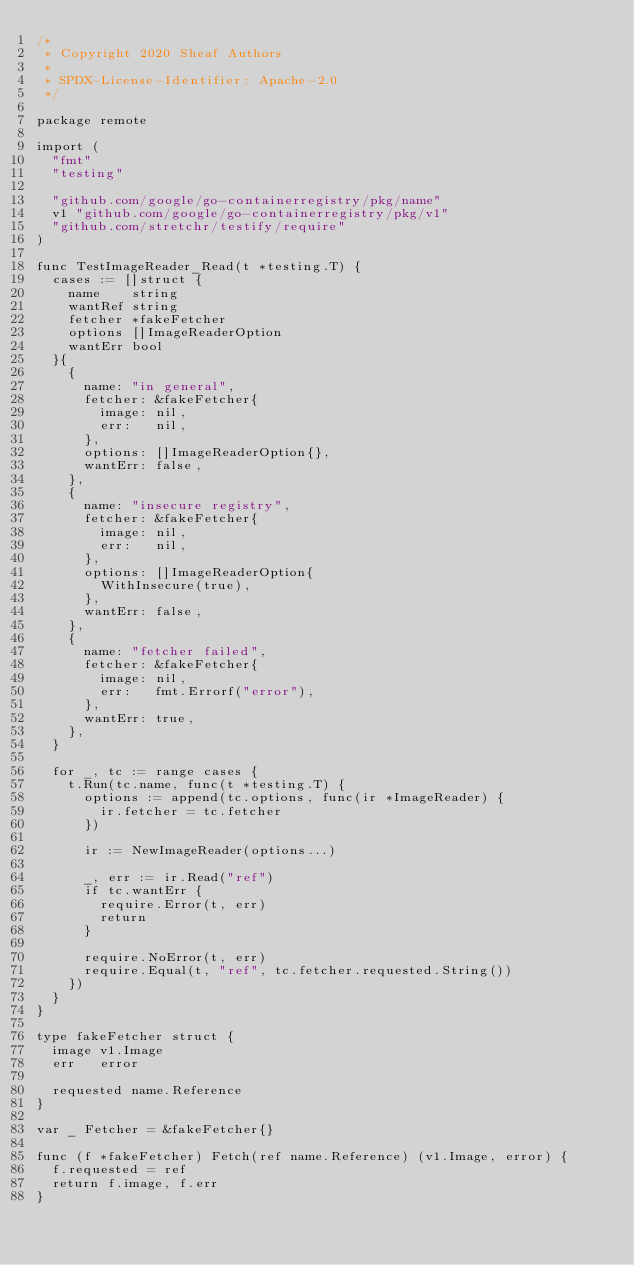<code> <loc_0><loc_0><loc_500><loc_500><_Go_>/*
 * Copyright 2020 Sheaf Authors
 *
 * SPDX-License-Identifier: Apache-2.0
 */

package remote

import (
	"fmt"
	"testing"

	"github.com/google/go-containerregistry/pkg/name"
	v1 "github.com/google/go-containerregistry/pkg/v1"
	"github.com/stretchr/testify/require"
)

func TestImageReader_Read(t *testing.T) {
	cases := []struct {
		name    string
		wantRef string
		fetcher *fakeFetcher
		options []ImageReaderOption
		wantErr bool
	}{
		{
			name: "in general",
			fetcher: &fakeFetcher{
				image: nil,
				err:   nil,
			},
			options: []ImageReaderOption{},
			wantErr: false,
		},
		{
			name: "insecure registry",
			fetcher: &fakeFetcher{
				image: nil,
				err:   nil,
			},
			options: []ImageReaderOption{
				WithInsecure(true),
			},
			wantErr: false,
		},
		{
			name: "fetcher failed",
			fetcher: &fakeFetcher{
				image: nil,
				err:   fmt.Errorf("error"),
			},
			wantErr: true,
		},
	}

	for _, tc := range cases {
		t.Run(tc.name, func(t *testing.T) {
			options := append(tc.options, func(ir *ImageReader) {
				ir.fetcher = tc.fetcher
			})

			ir := NewImageReader(options...)

			_, err := ir.Read("ref")
			if tc.wantErr {
				require.Error(t, err)
				return
			}

			require.NoError(t, err)
			require.Equal(t, "ref", tc.fetcher.requested.String())
		})
	}
}

type fakeFetcher struct {
	image v1.Image
	err   error

	requested name.Reference
}

var _ Fetcher = &fakeFetcher{}

func (f *fakeFetcher) Fetch(ref name.Reference) (v1.Image, error) {
	f.requested = ref
	return f.image, f.err
}
</code> 